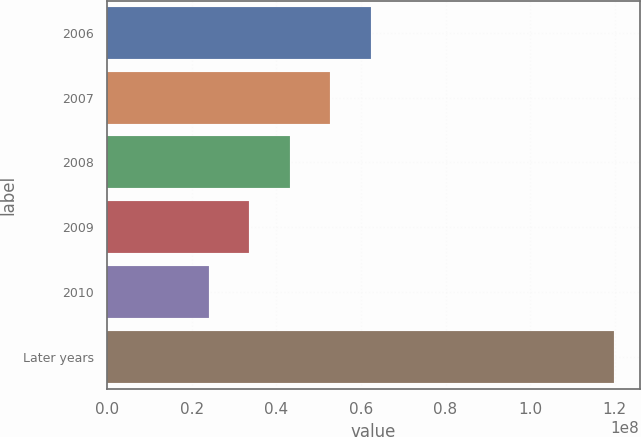<chart> <loc_0><loc_0><loc_500><loc_500><bar_chart><fcel>2006<fcel>2007<fcel>2008<fcel>2009<fcel>2010<fcel>Later years<nl><fcel>6.2322e+07<fcel>5.27275e+07<fcel>4.3133e+07<fcel>3.35385e+07<fcel>2.3944e+07<fcel>1.19889e+08<nl></chart> 